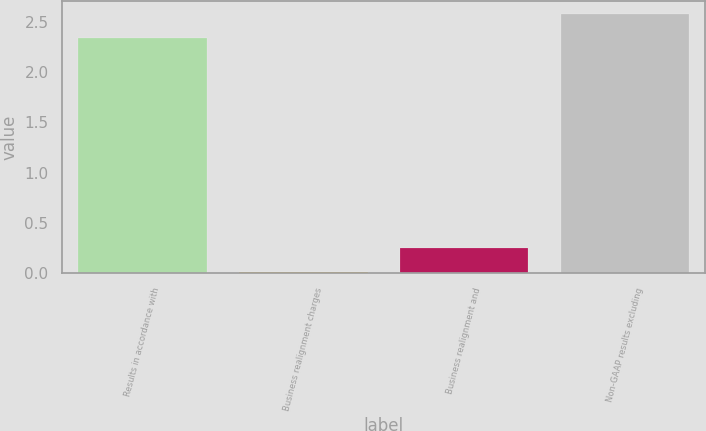<chart> <loc_0><loc_0><loc_500><loc_500><bar_chart><fcel>Results in accordance with<fcel>Business realignment charges<fcel>Business realignment and<fcel>Non-GAAP results excluding<nl><fcel>2.34<fcel>0.01<fcel>0.25<fcel>2.58<nl></chart> 